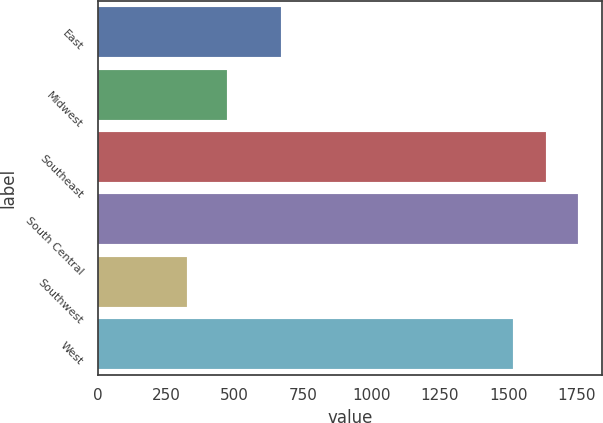Convert chart to OTSL. <chart><loc_0><loc_0><loc_500><loc_500><bar_chart><fcel>East<fcel>Midwest<fcel>Southeast<fcel>South Central<fcel>Southwest<fcel>West<nl><fcel>667.8<fcel>471.3<fcel>1636.11<fcel>1755.42<fcel>327.7<fcel>1516.8<nl></chart> 